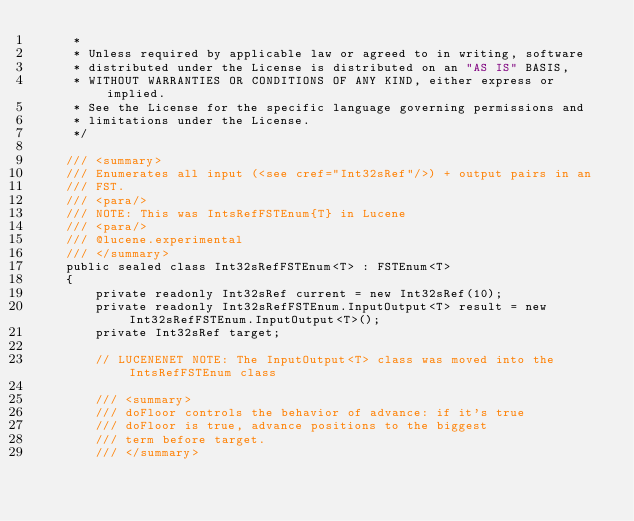<code> <loc_0><loc_0><loc_500><loc_500><_C#_>     *
     * Unless required by applicable law or agreed to in writing, software
     * distributed under the License is distributed on an "AS IS" BASIS,
     * WITHOUT WARRANTIES OR CONDITIONS OF ANY KIND, either express or implied.
     * See the License for the specific language governing permissions and
     * limitations under the License.
     */

    /// <summary>
    /// Enumerates all input (<see cref="Int32sRef"/>) + output pairs in an
    /// FST.
    /// <para/>
    /// NOTE: This was IntsRefFSTEnum{T} in Lucene
    /// <para/>
    /// @lucene.experimental
    /// </summary>
    public sealed class Int32sRefFSTEnum<T> : FSTEnum<T>
    {
        private readonly Int32sRef current = new Int32sRef(10);
        private readonly Int32sRefFSTEnum.InputOutput<T> result = new Int32sRefFSTEnum.InputOutput<T>();
        private Int32sRef target;

        // LUCENENET NOTE: The InputOutput<T> class was moved into the IntsRefFSTEnum class

        /// <summary>
        /// doFloor controls the behavior of advance: if it's true
        /// doFloor is true, advance positions to the biggest
        /// term before target.
        /// </summary></code> 